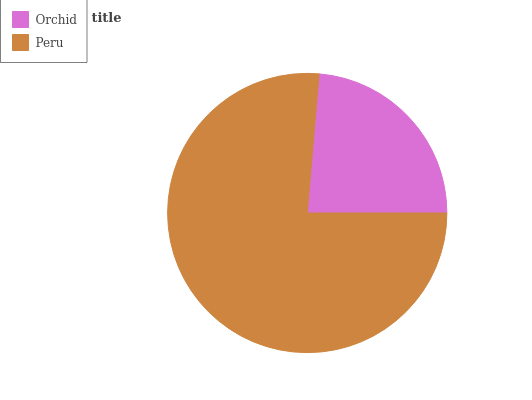Is Orchid the minimum?
Answer yes or no. Yes. Is Peru the maximum?
Answer yes or no. Yes. Is Peru the minimum?
Answer yes or no. No. Is Peru greater than Orchid?
Answer yes or no. Yes. Is Orchid less than Peru?
Answer yes or no. Yes. Is Orchid greater than Peru?
Answer yes or no. No. Is Peru less than Orchid?
Answer yes or no. No. Is Peru the high median?
Answer yes or no. Yes. Is Orchid the low median?
Answer yes or no. Yes. Is Orchid the high median?
Answer yes or no. No. Is Peru the low median?
Answer yes or no. No. 